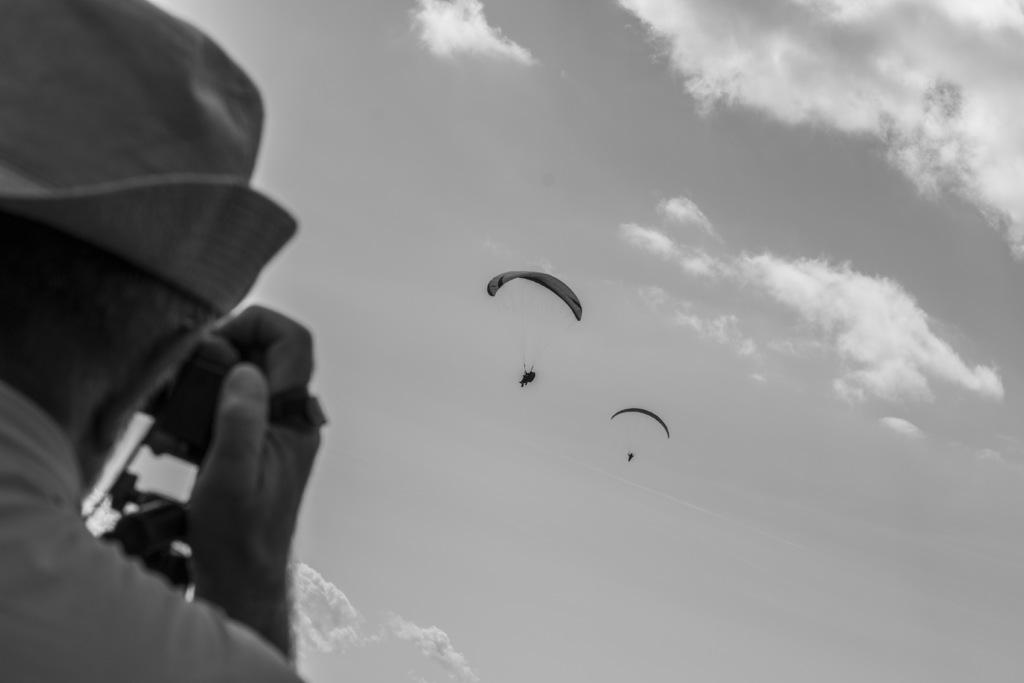What is located on the left side of the image? There is a person on the left side of the image. What can be seen in the background of the image? There are two parachutes and clouds visible in the sky in the background of the image. What type of anger can be seen on the person's face in the image? There is no indication of anger or any facial expression on the person's face in the image. How does the earthquake affect the parachutes in the image? There is no earthquake present in the image, and therefore no effect on the parachutes. 